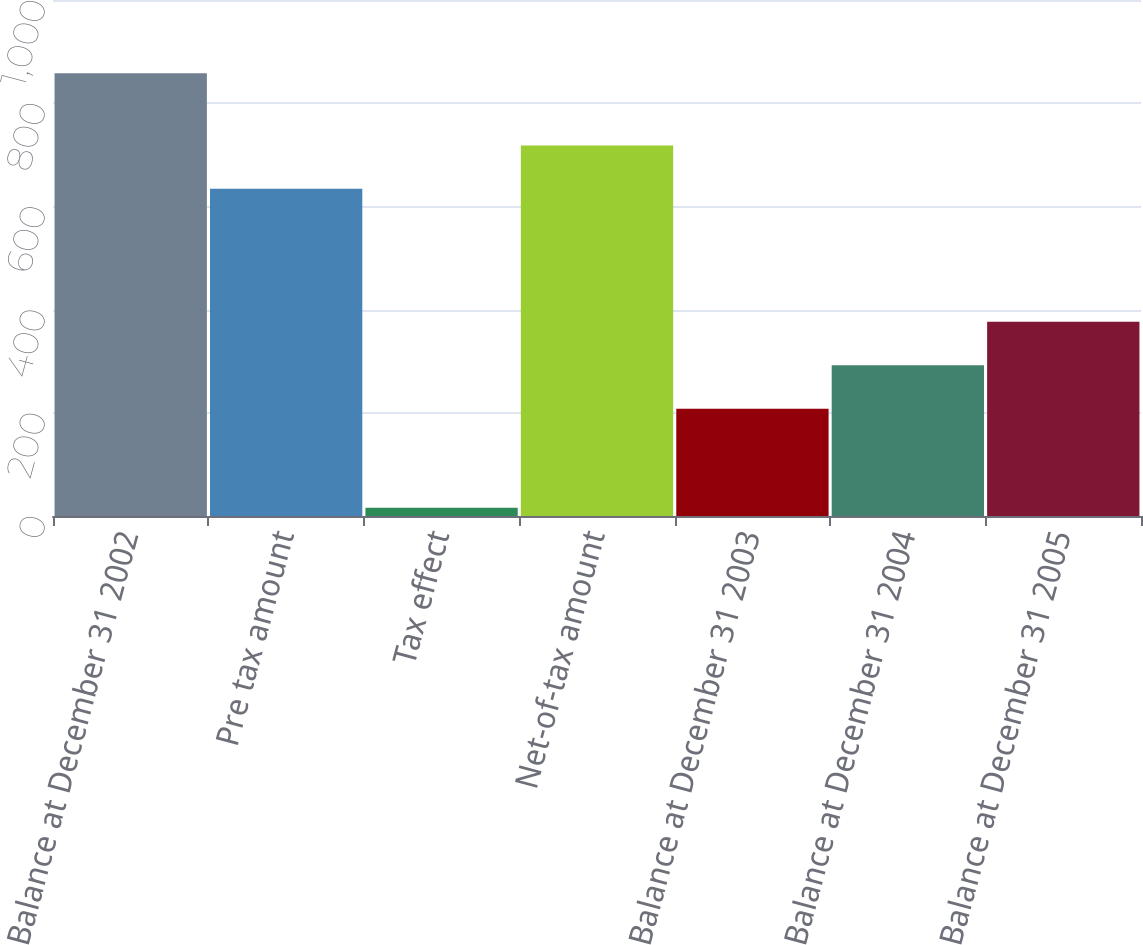Convert chart to OTSL. <chart><loc_0><loc_0><loc_500><loc_500><bar_chart><fcel>Balance at December 31 2002<fcel>Pre tax amount<fcel>Tax effect<fcel>Net-of-tax amount<fcel>Balance at December 31 2003<fcel>Balance at December 31 2004<fcel>Balance at December 31 2005<nl><fcel>858<fcel>634<fcel>16<fcel>718.2<fcel>208<fcel>292.2<fcel>376.4<nl></chart> 